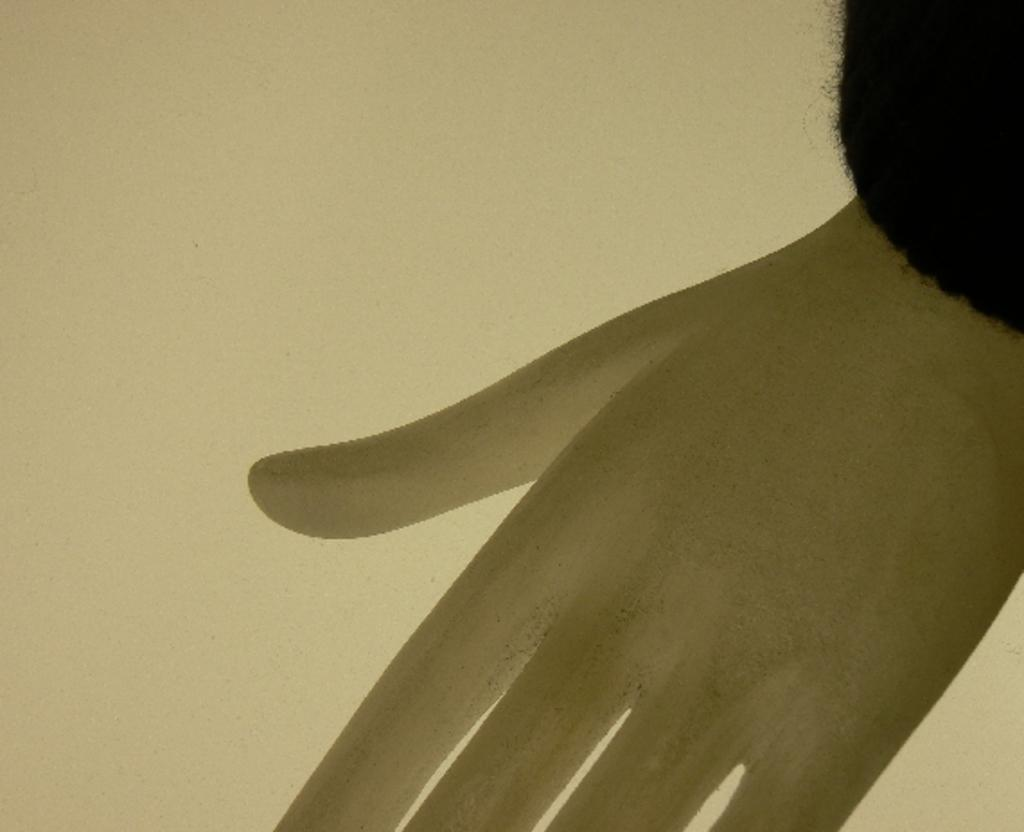What is the main subject in the center of the image? There is a hand of a mannequin in the center of the image. What can be seen in the background of the image? There is a wall in the background of the image. How many kittens are sitting on the collar of the mannequin in the image? There are no kittens or collars present in the image; it only features a hand of a mannequin and a wall in the background. 